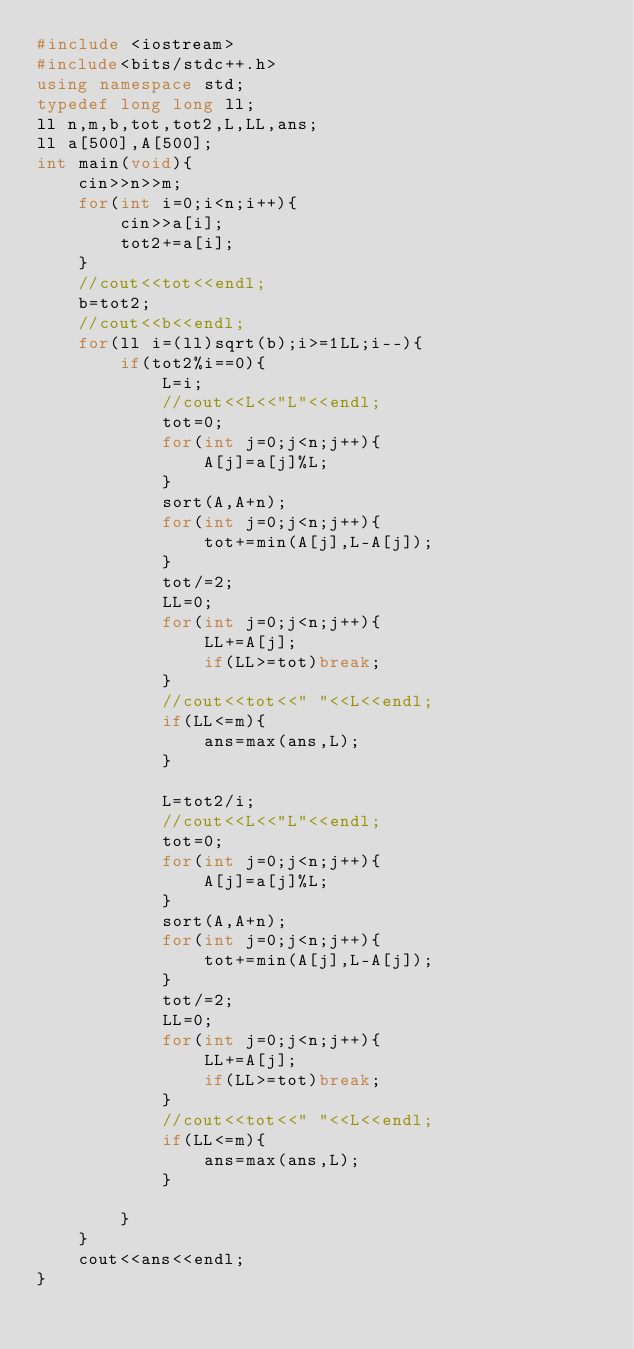Convert code to text. <code><loc_0><loc_0><loc_500><loc_500><_C++_>#include <iostream>
#include<bits/stdc++.h>
using namespace std;
typedef long long ll;
ll n,m,b,tot,tot2,L,LL,ans;
ll a[500],A[500];
int main(void){
    cin>>n>>m;
    for(int i=0;i<n;i++){
        cin>>a[i];
        tot2+=a[i];
    }
    //cout<<tot<<endl;
    b=tot2;
    //cout<<b<<endl;
    for(ll i=(ll)sqrt(b);i>=1LL;i--){
        if(tot2%i==0){
            L=i;
            //cout<<L<<"L"<<endl;
            tot=0;
            for(int j=0;j<n;j++){
                A[j]=a[j]%L;
            }
            sort(A,A+n);
            for(int j=0;j<n;j++){
                tot+=min(A[j],L-A[j]);
            }
            tot/=2;
            LL=0;
            for(int j=0;j<n;j++){
                LL+=A[j];
                if(LL>=tot)break;
            }
            //cout<<tot<<" "<<L<<endl;
            if(LL<=m){
                ans=max(ans,L);
            }
            
            L=tot2/i;
            //cout<<L<<"L"<<endl;
            tot=0;
            for(int j=0;j<n;j++){
                A[j]=a[j]%L;
            }
            sort(A,A+n);
            for(int j=0;j<n;j++){
                tot+=min(A[j],L-A[j]);
            }
            tot/=2;
            LL=0;
            for(int j=0;j<n;j++){
                LL+=A[j];
                if(LL>=tot)break;
            }
            //cout<<tot<<" "<<L<<endl;
            if(LL<=m){
                ans=max(ans,L);
            }
            
        }
    }
    cout<<ans<<endl;
}
</code> 